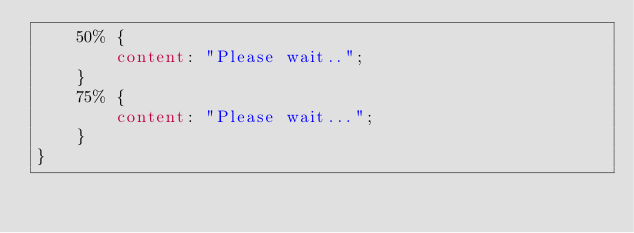Convert code to text. <code><loc_0><loc_0><loc_500><loc_500><_CSS_>    50% {
        content: "Please wait..";
    }
    75% {
        content: "Please wait...";
    }
}</code> 